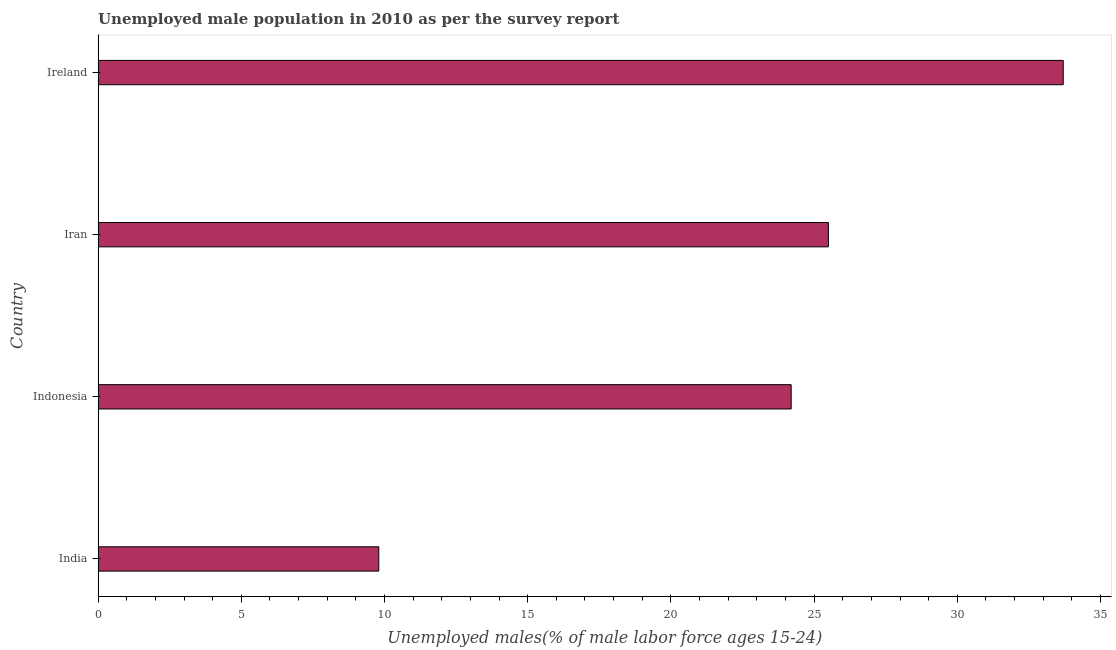What is the title of the graph?
Give a very brief answer. Unemployed male population in 2010 as per the survey report. What is the label or title of the X-axis?
Your answer should be compact. Unemployed males(% of male labor force ages 15-24). What is the label or title of the Y-axis?
Keep it short and to the point. Country. What is the unemployed male youth in Indonesia?
Make the answer very short. 24.2. Across all countries, what is the maximum unemployed male youth?
Ensure brevity in your answer.  33.7. Across all countries, what is the minimum unemployed male youth?
Ensure brevity in your answer.  9.8. In which country was the unemployed male youth maximum?
Your answer should be very brief. Ireland. What is the sum of the unemployed male youth?
Offer a very short reply. 93.2. What is the difference between the unemployed male youth in India and Iran?
Keep it short and to the point. -15.7. What is the average unemployed male youth per country?
Your answer should be very brief. 23.3. What is the median unemployed male youth?
Your answer should be compact. 24.85. What is the ratio of the unemployed male youth in India to that in Ireland?
Give a very brief answer. 0.29. Is the unemployed male youth in Iran less than that in Ireland?
Make the answer very short. Yes. Is the difference between the unemployed male youth in Iran and Ireland greater than the difference between any two countries?
Give a very brief answer. No. What is the difference between the highest and the second highest unemployed male youth?
Your answer should be very brief. 8.2. What is the difference between the highest and the lowest unemployed male youth?
Ensure brevity in your answer.  23.9. In how many countries, is the unemployed male youth greater than the average unemployed male youth taken over all countries?
Your answer should be compact. 3. Are all the bars in the graph horizontal?
Keep it short and to the point. Yes. What is the difference between two consecutive major ticks on the X-axis?
Provide a short and direct response. 5. What is the Unemployed males(% of male labor force ages 15-24) in India?
Your response must be concise. 9.8. What is the Unemployed males(% of male labor force ages 15-24) of Indonesia?
Give a very brief answer. 24.2. What is the Unemployed males(% of male labor force ages 15-24) of Iran?
Your answer should be very brief. 25.5. What is the Unemployed males(% of male labor force ages 15-24) in Ireland?
Your answer should be very brief. 33.7. What is the difference between the Unemployed males(% of male labor force ages 15-24) in India and Indonesia?
Your answer should be very brief. -14.4. What is the difference between the Unemployed males(% of male labor force ages 15-24) in India and Iran?
Make the answer very short. -15.7. What is the difference between the Unemployed males(% of male labor force ages 15-24) in India and Ireland?
Ensure brevity in your answer.  -23.9. What is the difference between the Unemployed males(% of male labor force ages 15-24) in Indonesia and Iran?
Provide a short and direct response. -1.3. What is the difference between the Unemployed males(% of male labor force ages 15-24) in Iran and Ireland?
Offer a very short reply. -8.2. What is the ratio of the Unemployed males(% of male labor force ages 15-24) in India to that in Indonesia?
Provide a succinct answer. 0.41. What is the ratio of the Unemployed males(% of male labor force ages 15-24) in India to that in Iran?
Offer a very short reply. 0.38. What is the ratio of the Unemployed males(% of male labor force ages 15-24) in India to that in Ireland?
Your answer should be very brief. 0.29. What is the ratio of the Unemployed males(% of male labor force ages 15-24) in Indonesia to that in Iran?
Make the answer very short. 0.95. What is the ratio of the Unemployed males(% of male labor force ages 15-24) in Indonesia to that in Ireland?
Make the answer very short. 0.72. What is the ratio of the Unemployed males(% of male labor force ages 15-24) in Iran to that in Ireland?
Make the answer very short. 0.76. 